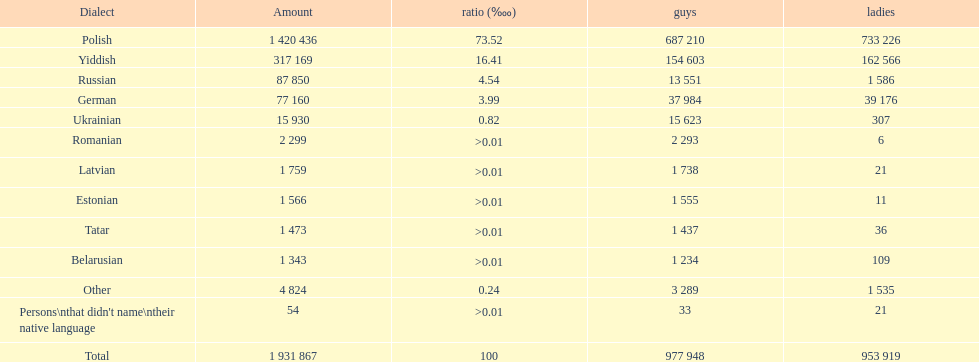Which language had the smallest number of females speaking it. Romanian. 